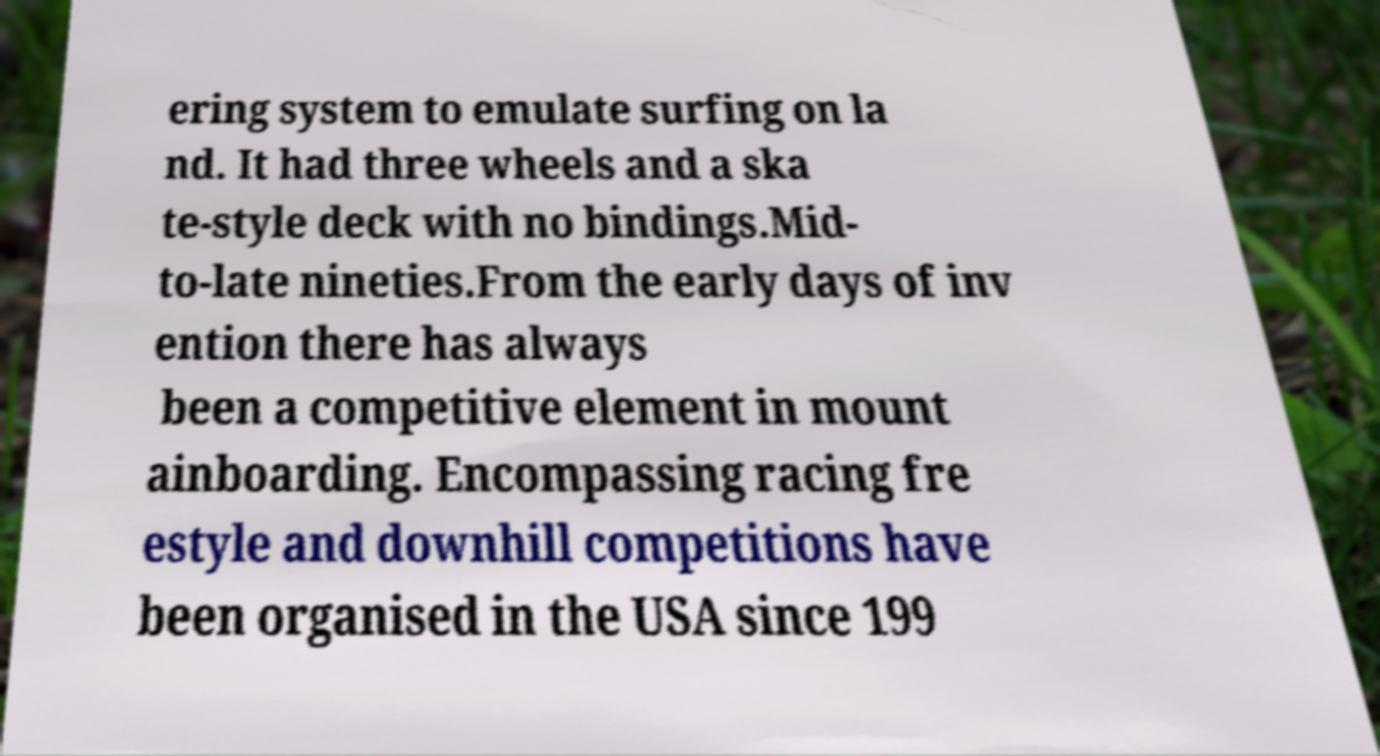Please identify and transcribe the text found in this image. ering system to emulate surfing on la nd. It had three wheels and a ska te-style deck with no bindings.Mid- to-late nineties.From the early days of inv ention there has always been a competitive element in mount ainboarding. Encompassing racing fre estyle and downhill competitions have been organised in the USA since 199 